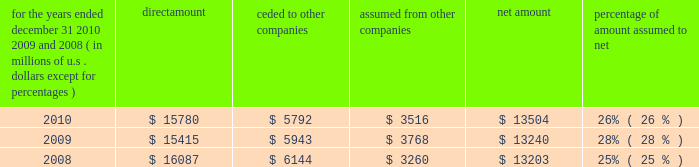S c h e d u l e i v ace limited and subsidiaries s u p p l e m e n t a l i n f o r m a t i o n c o n c e r n i n g r e i n s u r a n c e premiums earned for the years ended december 31 , 2010 , 2009 , and 2008 ( in millions of u.s .
Dollars , except for percentages ) direct amount ceded to companies assumed from other companies net amount percentage of amount assumed to .

What is the growth rate in direct amount from 2009 to 2010? 
Computations: ((15780 - 15415) / 15415)
Answer: 0.02368. 